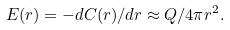Convert formula to latex. <formula><loc_0><loc_0><loc_500><loc_500>E ( r ) = - d C ( r ) / d r \approx Q / 4 \pi r ^ { 2 } .</formula> 